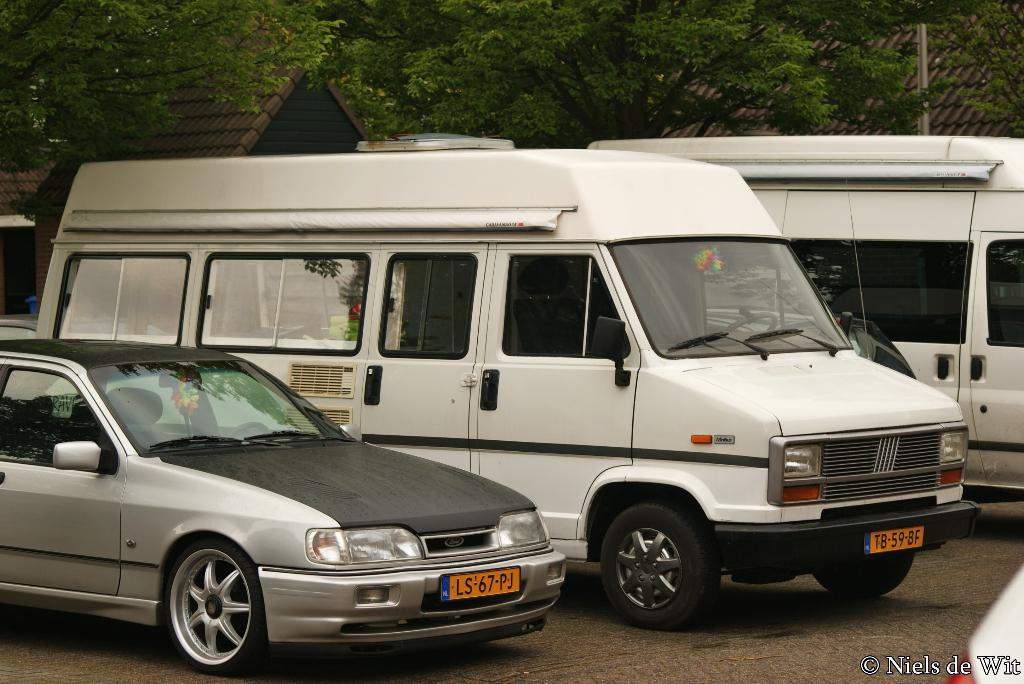Provide a one-sentence caption for the provided image. A car with the license plate LS-67-PK is parked next to a white truck. 